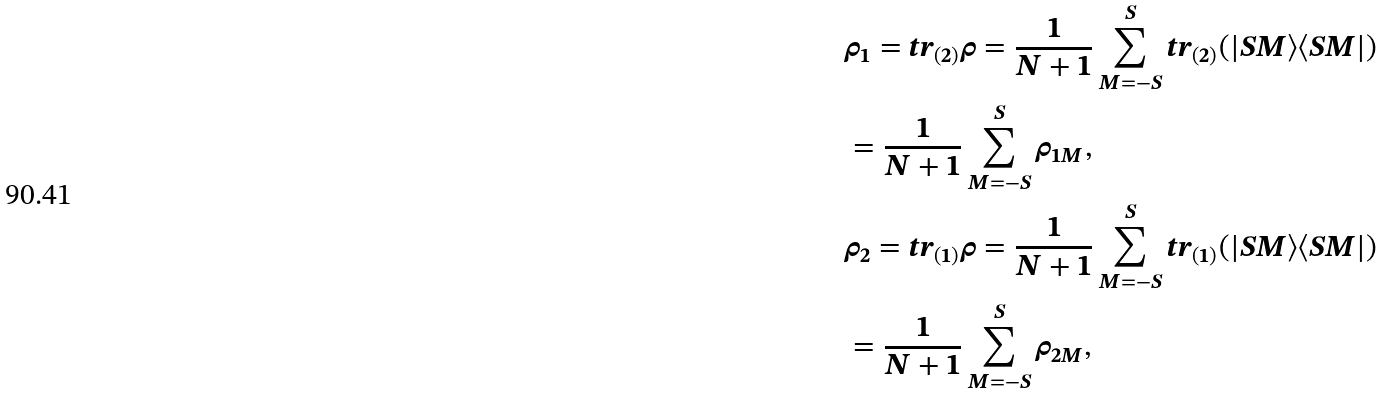<formula> <loc_0><loc_0><loc_500><loc_500>& \rho _ { 1 } = t r _ { ( 2 ) } \rho = \frac { 1 } { N + 1 } \sum _ { M = - S } ^ { S } t r _ { ( 2 ) } ( | S M \rangle \langle S M | ) \\ & = \frac { 1 } { N + 1 } \sum _ { M = - S } ^ { S } \rho _ { 1 M } , \\ & \rho _ { 2 } = t r _ { ( 1 ) } \rho = \frac { 1 } { N + 1 } \sum _ { M = - S } ^ { S } t r _ { ( 1 ) } ( | S M \rangle \langle S M | ) \\ & = \frac { 1 } { N + 1 } \sum _ { M = - S } ^ { S } \rho _ { 2 M } ,</formula> 